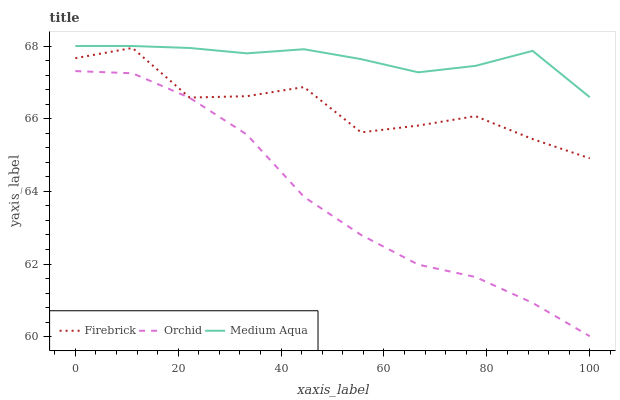Does Orchid have the minimum area under the curve?
Answer yes or no. Yes. Does Medium Aqua have the maximum area under the curve?
Answer yes or no. Yes. Does Medium Aqua have the minimum area under the curve?
Answer yes or no. No. Does Orchid have the maximum area under the curve?
Answer yes or no. No. Is Medium Aqua the smoothest?
Answer yes or no. Yes. Is Firebrick the roughest?
Answer yes or no. Yes. Is Orchid the smoothest?
Answer yes or no. No. Is Orchid the roughest?
Answer yes or no. No. Does Orchid have the lowest value?
Answer yes or no. Yes. Does Medium Aqua have the lowest value?
Answer yes or no. No. Does Medium Aqua have the highest value?
Answer yes or no. Yes. Does Orchid have the highest value?
Answer yes or no. No. Is Orchid less than Firebrick?
Answer yes or no. Yes. Is Medium Aqua greater than Orchid?
Answer yes or no. Yes. Does Orchid intersect Firebrick?
Answer yes or no. No. 